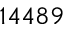<formula> <loc_0><loc_0><loc_500><loc_500>1 4 4 8 9</formula> 